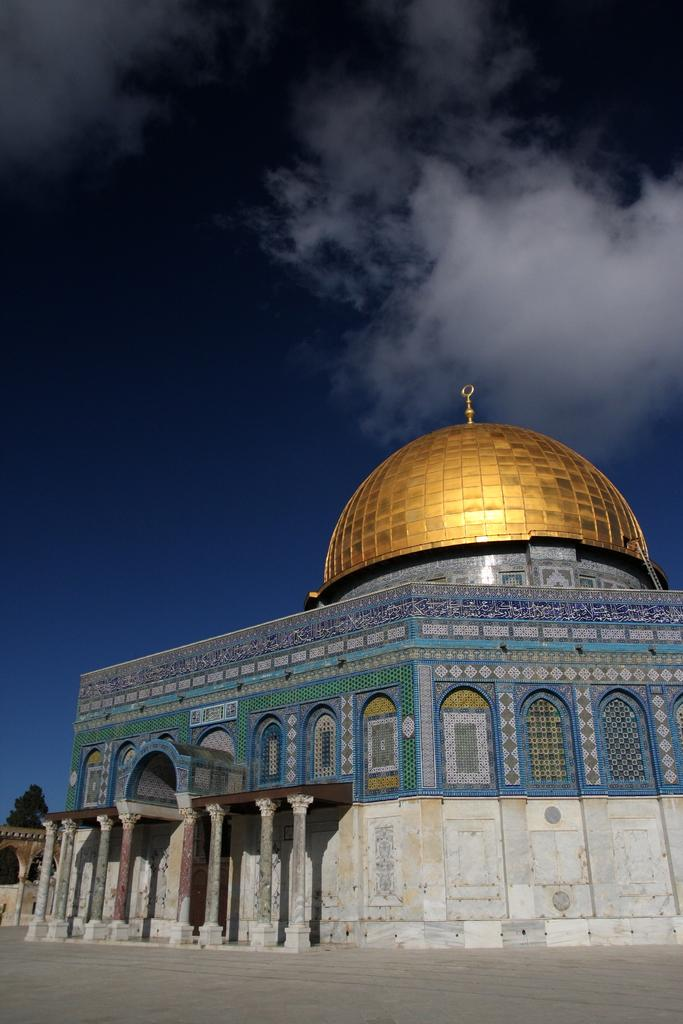What type of structure is present in the image? There is a building in the image. What can be seen in the sky in the image? There are clouds visible in the image. What part of the natural environment is visible in the image? The sky is visible in the background of the image. What activity is the building participating in during this minute? The building is not capable of participating in any activity, as it is an inanimate structure. 